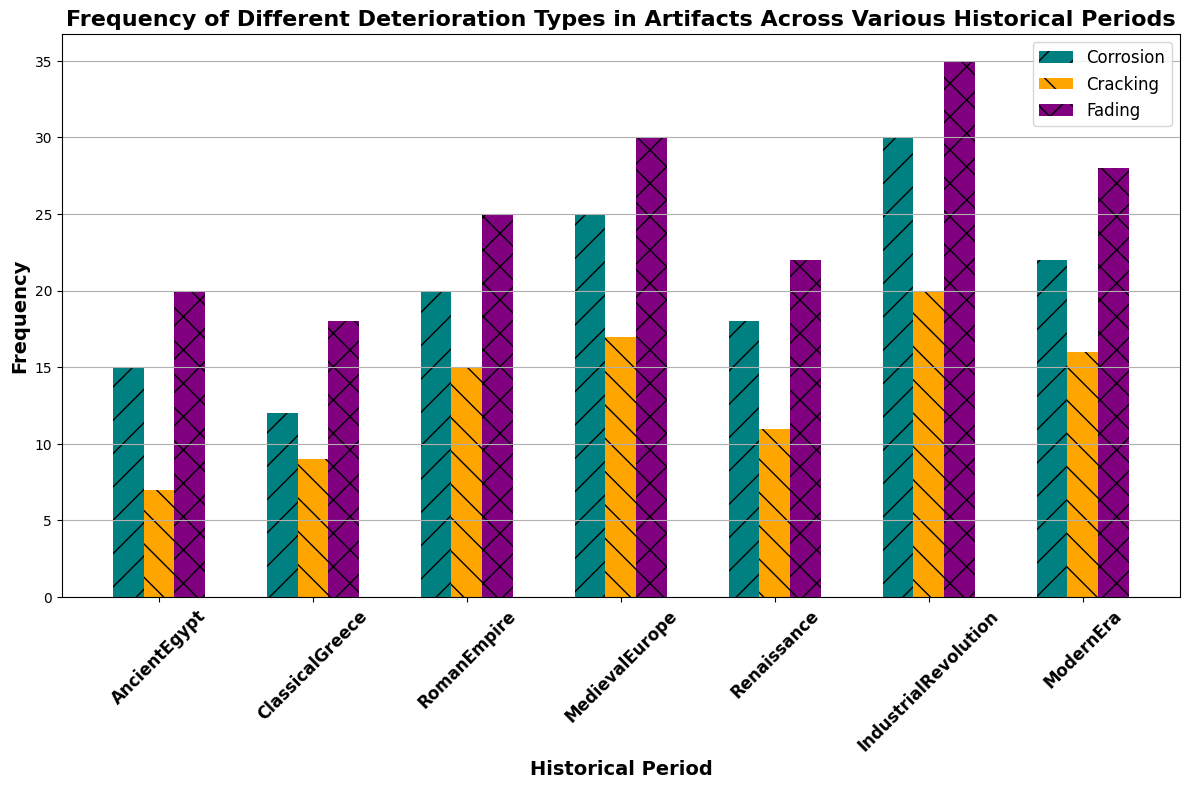Which historical period shows the highest frequency of corrosion? To find the period with the highest corrosion frequency, we identify the tallest teal-colored bar. The bar corresponding to the Industrial Revolution period is the highest among the corrosion bars.
Answer: Industrial Revolution Between Ancient Egypt and Classical Greece, which period has more instances of cracking? Compare the heights of the orange-colored bars for both periods. The cracking bar for Classical Greece is higher than that for Ancient Egypt.
Answer: Classical Greece What is the total frequency of fading in both the Roman Empire and Medieval Europe periods? Add the frequency values of fading for the Roman Empire (25) and Medieval Europe (30).
Answer: 55 Which type of deterioration is least frequent in the Modern Era? Examine the heights of all bars during the Modern Era period. The shortest bar corresponds to cracking (orange bar).
Answer: Cracking How much more frequent is corrosion than fading in the Renaissance period? Compare the corrosion (teal) and fading (purple) bars in the Renaissance period. Subtract the frequency of fading (22) from the frequency of corrosion (18). The result is -4, indicating that corrosion is actually less frequent than fading in the Renaissance.
Answer: -4 Which two periods have the highest combined frequency of all deterioration types? Calculate the total frequency for each period by adding up corrosion, cracking, and fading values. Then, compare these totals to determine the two highest.
Answer: Industrial Revolution and Medieval Europe What is the average frequency of corrosion across all historical periods? Sum the corrosion frequencies (15, 12, 20, 25, 18, 30, 22), then divide by the total number of periods (7). The sum is 142, and the average is 142 / 7.
Answer: 20.3 In which periods do either cracking or fading have equally high frequencies as another type of deterioration? Look for periods where the heights of the orange (cracking) and purple (fading) bars are equal or nearly equal to any other type of deterioration bar. No such period exists.
Answer: None What is the proportion of cracking to the total deterioration in the Industrial Revolution period? To find this, first sum the frequencies of all deterioration types in the Industrial Revolution period (30 for corrosion, 20 for cracking, 35 for fading = 85). Then, calculate the proportion by dividing the cracking frequency (20) by the total (85). Simplified, that's 20/85.
Answer: 20/85 or approximately 23.5% How does the frequency of deterioration in the Roman Empire relate to that of the Medieval Europe period for each type? Compare corrosion, cracking, and fading separately between the two periods. Corrosion: 20 (Roman) < 25 (Medieval); Cracking: 15 (Roman) < 17 (Medieval); Fading: 25 (Roman) < 30 (Medieval). All types of deterioration are more frequent in the Medieval Europe period compared to the Roman Empire.
Answer: All types more frequent in Medieval Europe 